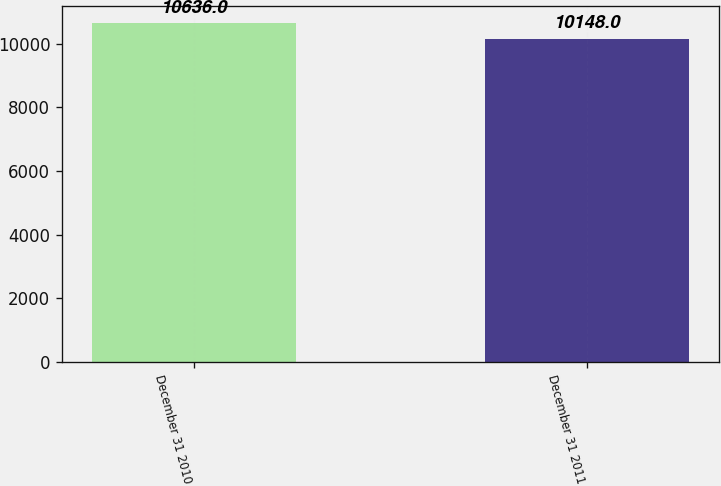Convert chart to OTSL. <chart><loc_0><loc_0><loc_500><loc_500><bar_chart><fcel>December 31 2010<fcel>December 31 2011<nl><fcel>10636<fcel>10148<nl></chart> 